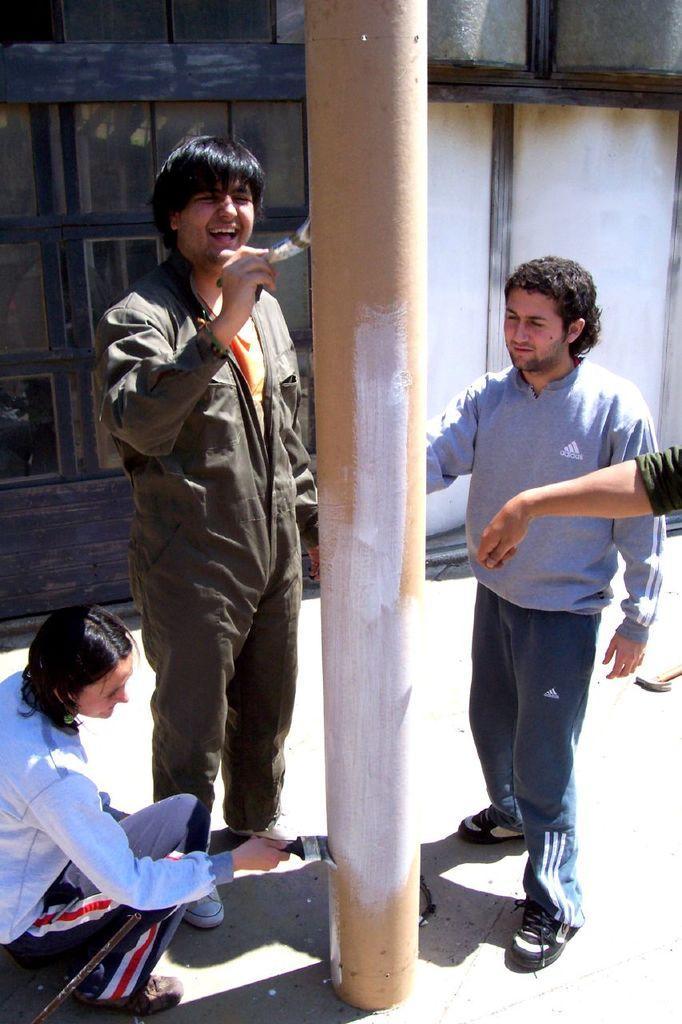In one or two sentences, can you explain what this image depicts? In the image there is a pole and a group of people are painting the pole, behind them there is a window. 